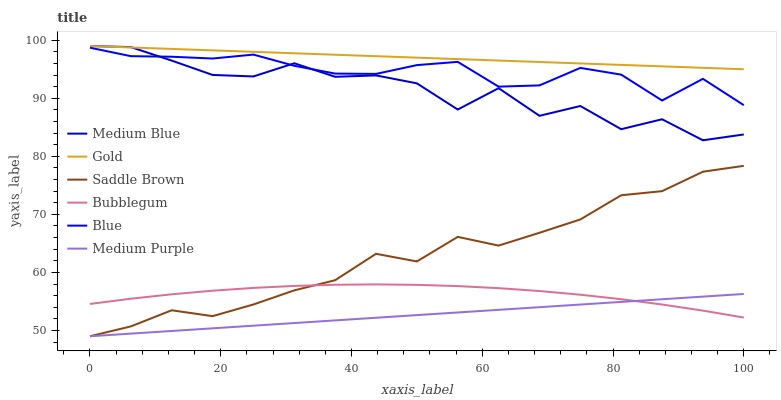Does Medium Purple have the minimum area under the curve?
Answer yes or no. Yes. Does Gold have the maximum area under the curve?
Answer yes or no. Yes. Does Medium Blue have the minimum area under the curve?
Answer yes or no. No. Does Medium Blue have the maximum area under the curve?
Answer yes or no. No. Is Gold the smoothest?
Answer yes or no. Yes. Is Medium Blue the roughest?
Answer yes or no. Yes. Is Medium Blue the smoothest?
Answer yes or no. No. Is Gold the roughest?
Answer yes or no. No. Does Medium Blue have the lowest value?
Answer yes or no. No. Does Bubblegum have the highest value?
Answer yes or no. No. Is Blue less than Gold?
Answer yes or no. Yes. Is Gold greater than Bubblegum?
Answer yes or no. Yes. Does Blue intersect Gold?
Answer yes or no. No. 